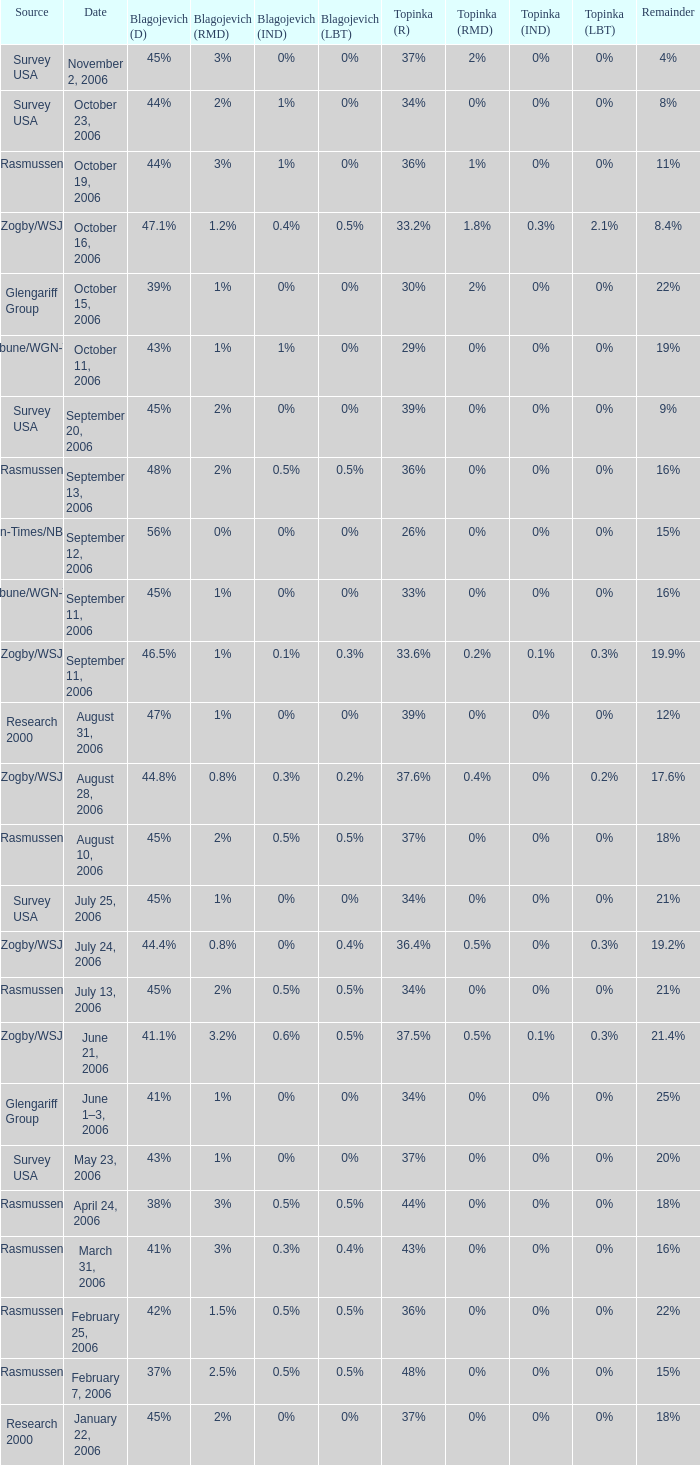Which blagojevich (d) possesses a zogby/wsj source and a topinka (r) at 3 47.1%. 